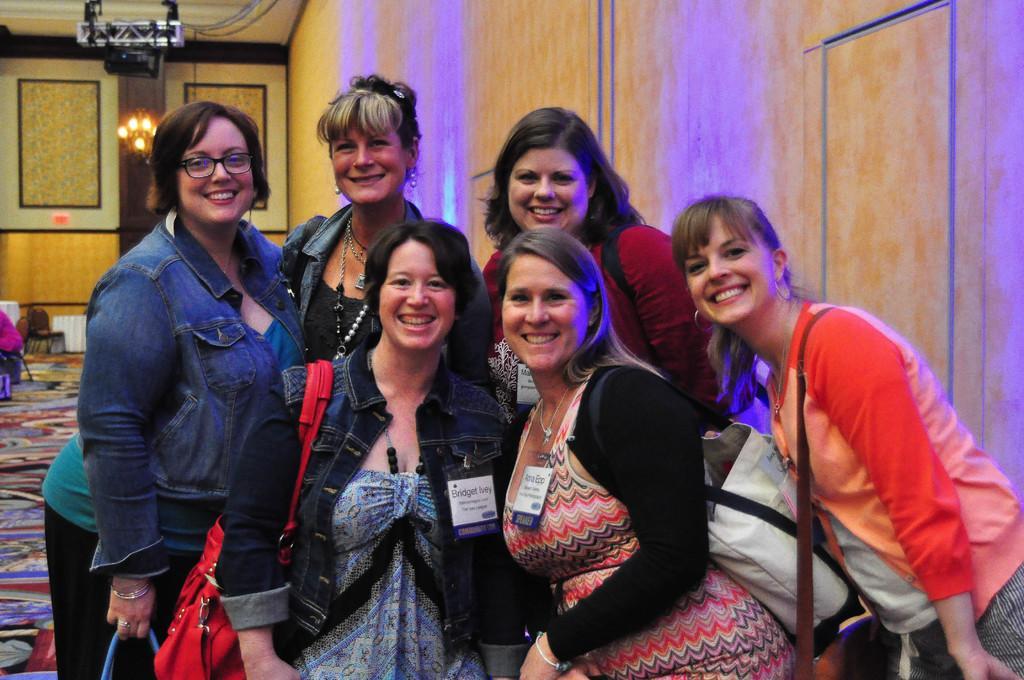Describe this image in one or two sentences. In this image I can see six women standing and posing for the picture. I can see a metal object hanging on the roof. I can see some lights on a wooden wall behind. I can see some objects on the floor. 